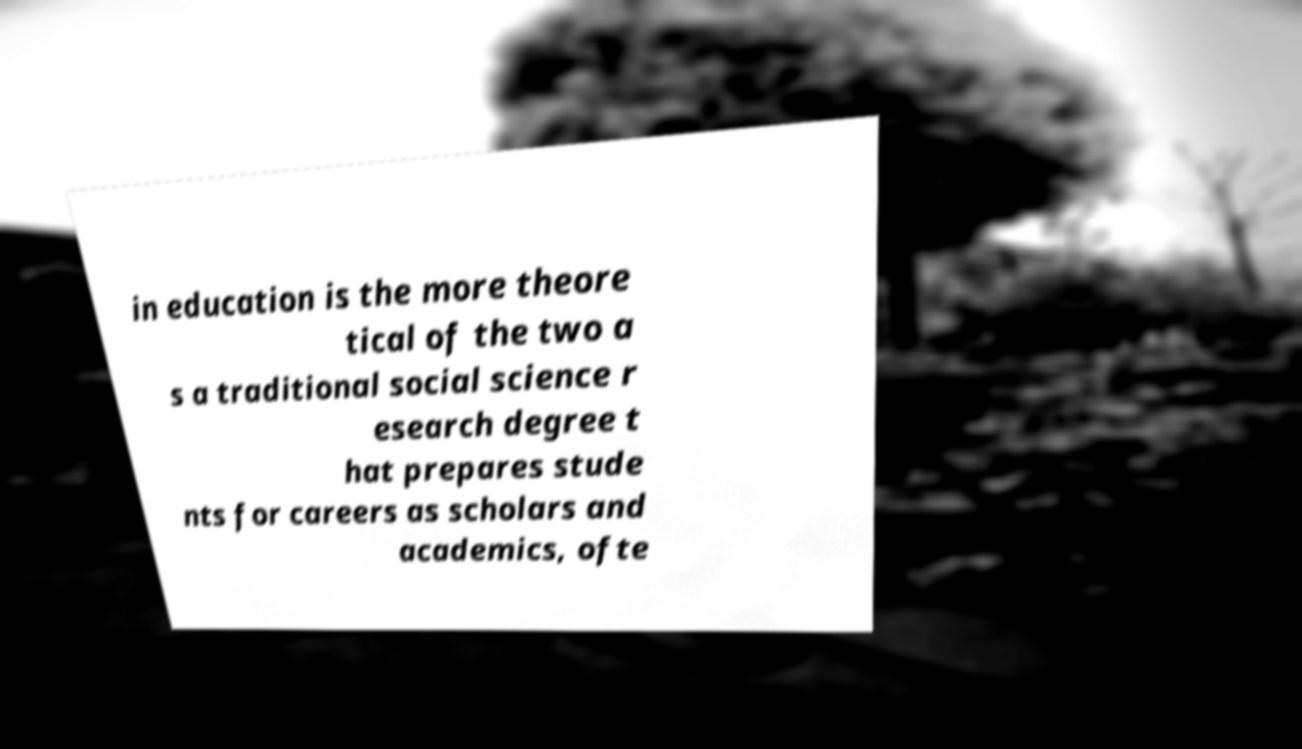There's text embedded in this image that I need extracted. Can you transcribe it verbatim? in education is the more theore tical of the two a s a traditional social science r esearch degree t hat prepares stude nts for careers as scholars and academics, ofte 